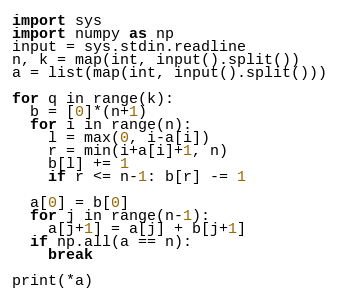<code> <loc_0><loc_0><loc_500><loc_500><_Python_>import sys
import numpy as np
input = sys.stdin.readline
n, k = map(int, input().split())
a = list(map(int, input().split()))

for q in range(k):
  b = [0]*(n+1)
  for i in range(n):
    l = max(0, i-a[i])
    r = min(i+a[i]+1, n)
    b[l] += 1
    if r <= n-1: b[r] -= 1
      
  a[0] = b[0]
  for j in range(n-1):
    a[j+1] = a[j] + b[j+1]
  if np.all(a == n):
    break

print(*a)</code> 